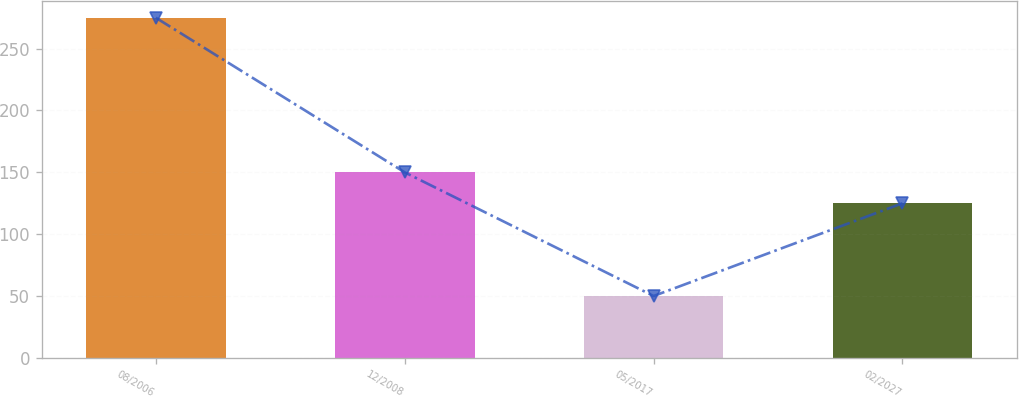Convert chart to OTSL. <chart><loc_0><loc_0><loc_500><loc_500><bar_chart><fcel>08/2006<fcel>12/2008<fcel>05/2017<fcel>02/2027<nl><fcel>275<fcel>150<fcel>50<fcel>125<nl></chart> 